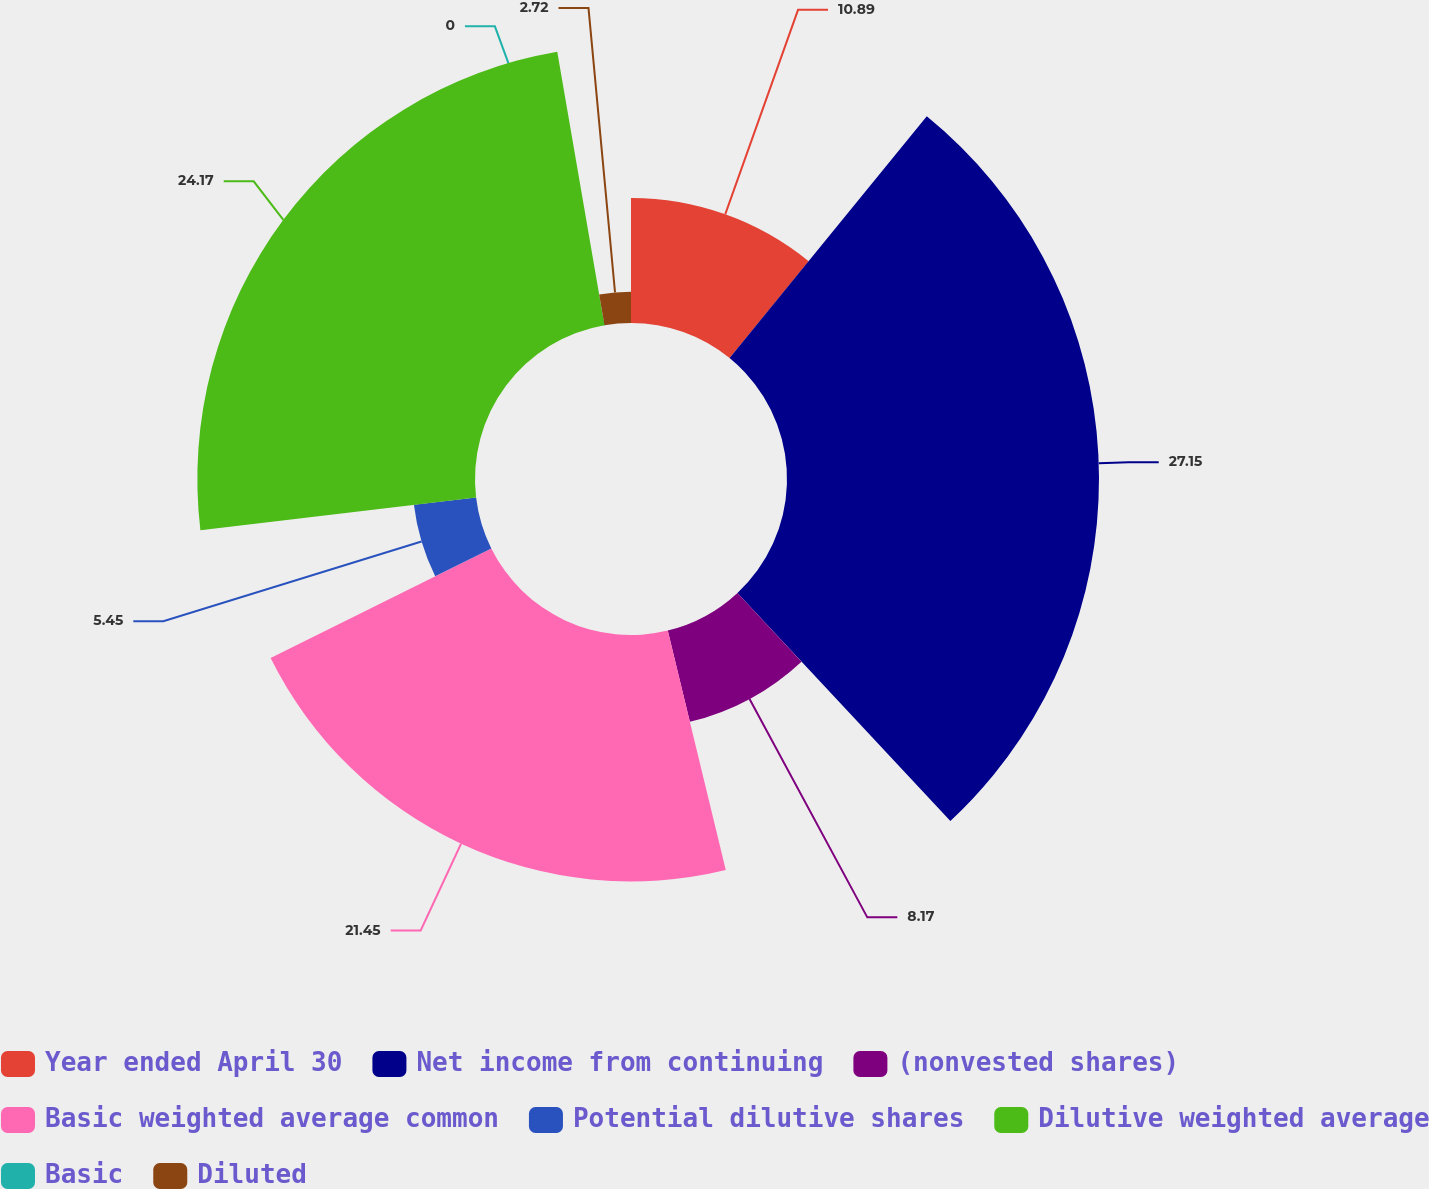Convert chart. <chart><loc_0><loc_0><loc_500><loc_500><pie_chart><fcel>Year ended April 30<fcel>Net income from continuing<fcel>(nonvested shares)<fcel>Basic weighted average common<fcel>Potential dilutive shares<fcel>Dilutive weighted average<fcel>Basic<fcel>Diluted<nl><fcel>10.89%<fcel>27.16%<fcel>8.17%<fcel>21.45%<fcel>5.45%<fcel>24.17%<fcel>0.0%<fcel>2.72%<nl></chart> 